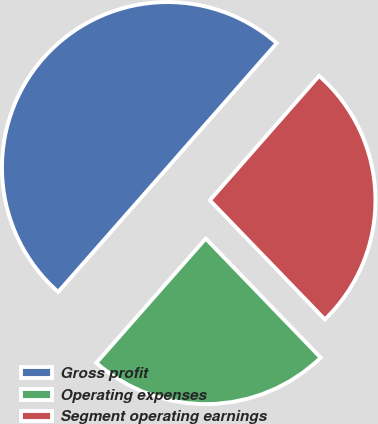Convert chart to OTSL. <chart><loc_0><loc_0><loc_500><loc_500><pie_chart><fcel>Gross profit<fcel>Operating expenses<fcel>Segment operating earnings<nl><fcel>49.98%<fcel>23.7%<fcel>26.32%<nl></chart> 